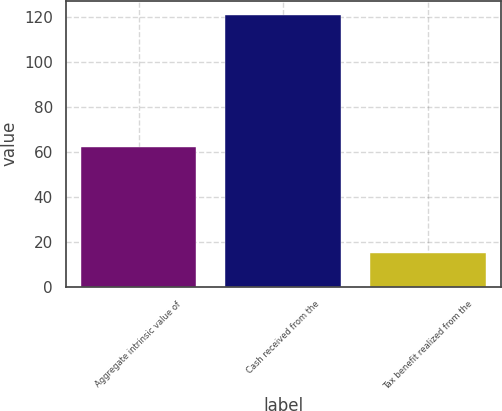Convert chart. <chart><loc_0><loc_0><loc_500><loc_500><bar_chart><fcel>Aggregate intrinsic value of<fcel>Cash received from the<fcel>Tax benefit realized from the<nl><fcel>62<fcel>121<fcel>15<nl></chart> 